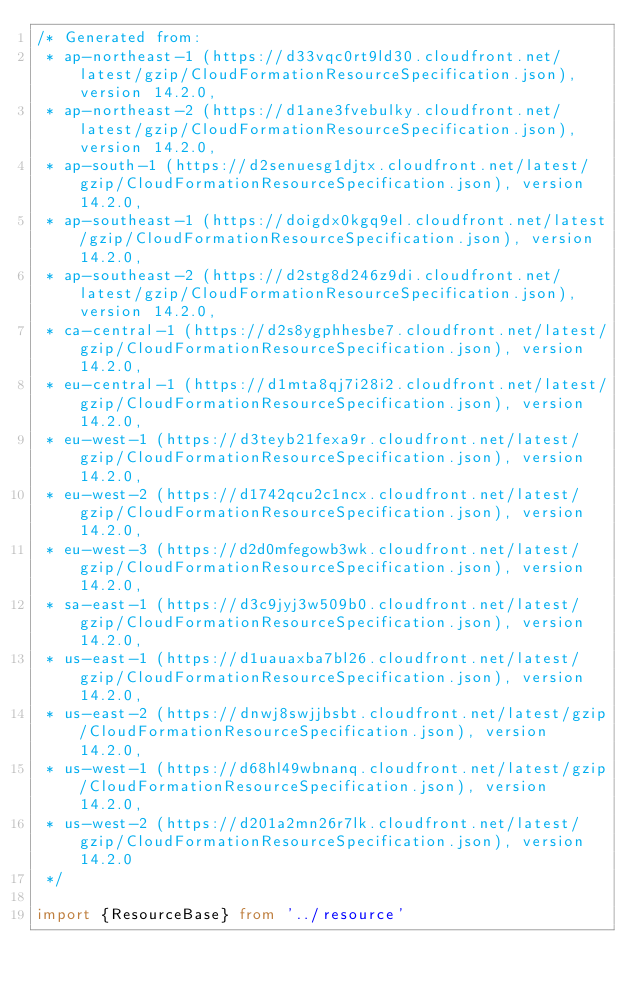<code> <loc_0><loc_0><loc_500><loc_500><_TypeScript_>/* Generated from: 
 * ap-northeast-1 (https://d33vqc0rt9ld30.cloudfront.net/latest/gzip/CloudFormationResourceSpecification.json), version 14.2.0,
 * ap-northeast-2 (https://d1ane3fvebulky.cloudfront.net/latest/gzip/CloudFormationResourceSpecification.json), version 14.2.0,
 * ap-south-1 (https://d2senuesg1djtx.cloudfront.net/latest/gzip/CloudFormationResourceSpecification.json), version 14.2.0,
 * ap-southeast-1 (https://doigdx0kgq9el.cloudfront.net/latest/gzip/CloudFormationResourceSpecification.json), version 14.2.0,
 * ap-southeast-2 (https://d2stg8d246z9di.cloudfront.net/latest/gzip/CloudFormationResourceSpecification.json), version 14.2.0,
 * ca-central-1 (https://d2s8ygphhesbe7.cloudfront.net/latest/gzip/CloudFormationResourceSpecification.json), version 14.2.0,
 * eu-central-1 (https://d1mta8qj7i28i2.cloudfront.net/latest/gzip/CloudFormationResourceSpecification.json), version 14.2.0,
 * eu-west-1 (https://d3teyb21fexa9r.cloudfront.net/latest/gzip/CloudFormationResourceSpecification.json), version 14.2.0,
 * eu-west-2 (https://d1742qcu2c1ncx.cloudfront.net/latest/gzip/CloudFormationResourceSpecification.json), version 14.2.0,
 * eu-west-3 (https://d2d0mfegowb3wk.cloudfront.net/latest/gzip/CloudFormationResourceSpecification.json), version 14.2.0,
 * sa-east-1 (https://d3c9jyj3w509b0.cloudfront.net/latest/gzip/CloudFormationResourceSpecification.json), version 14.2.0,
 * us-east-1 (https://d1uauaxba7bl26.cloudfront.net/latest/gzip/CloudFormationResourceSpecification.json), version 14.2.0,
 * us-east-2 (https://dnwj8swjjbsbt.cloudfront.net/latest/gzip/CloudFormationResourceSpecification.json), version 14.2.0,
 * us-west-1 (https://d68hl49wbnanq.cloudfront.net/latest/gzip/CloudFormationResourceSpecification.json), version 14.2.0,
 * us-west-2 (https://d201a2mn26r7lk.cloudfront.net/latest/gzip/CloudFormationResourceSpecification.json), version 14.2.0
 */
   
import {ResourceBase} from '../resource'</code> 